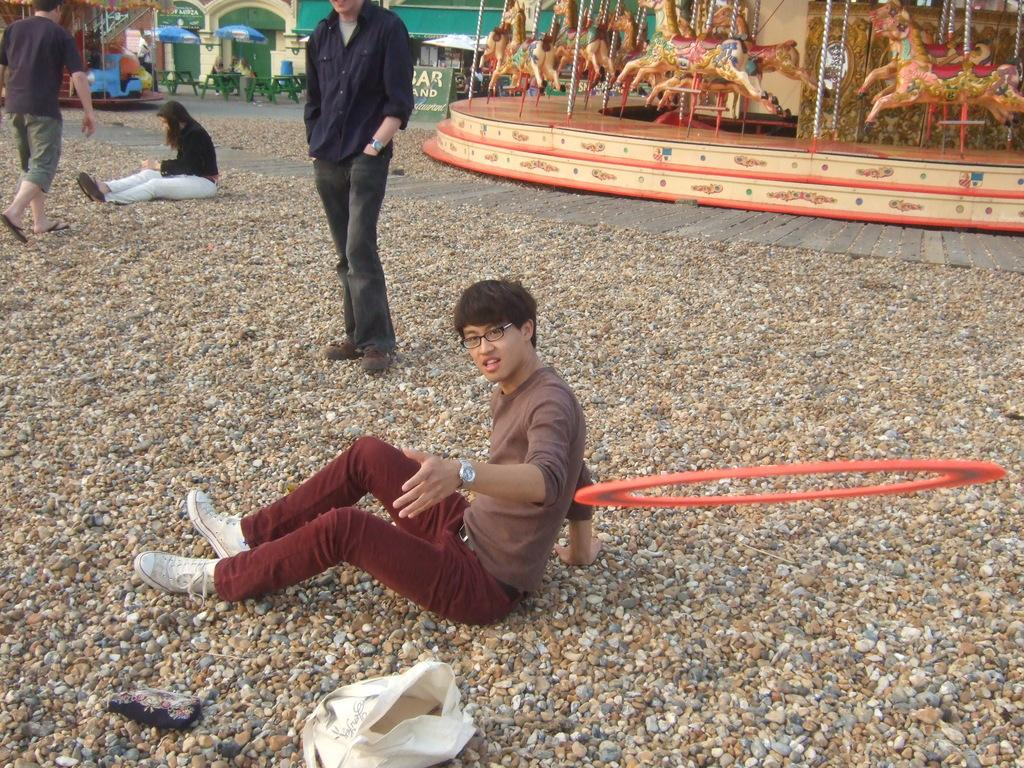How many people are in the image? There are people in the image, but the exact number is not specified. What is the circular object in the air? There is a circular object in the air, but its nature or purpose is not described. What is the bag placed on in the image? The bag is placed on stones in the image. What can be seen in the background of the image? In the background of the image, there are rides, umbrellas, tables, a board, and other objects. What word does the person in the image say as they leave? There is no indication in the image that anyone is leaving or saying goodbye, so it is not possible to determine what word they might say. 